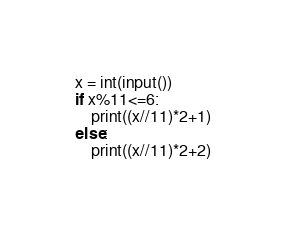<code> <loc_0><loc_0><loc_500><loc_500><_Python_>x = int(input())
if x%11<=6:
    print((x//11)*2+1)
else:
    print((x//11)*2+2)</code> 